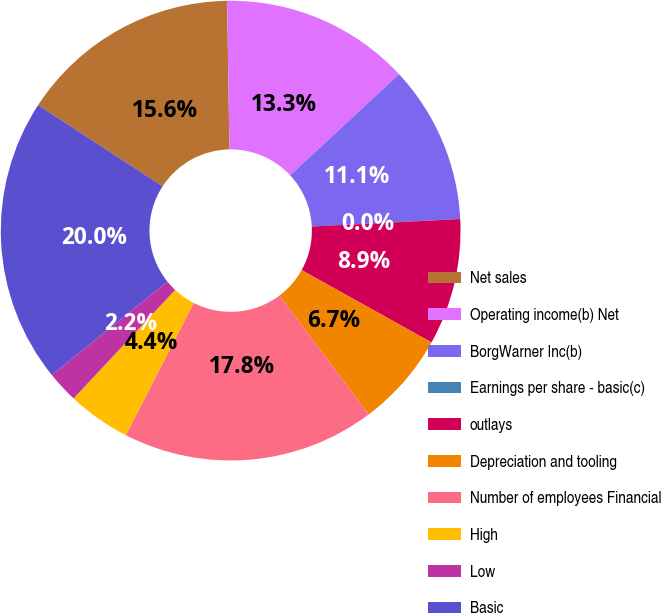<chart> <loc_0><loc_0><loc_500><loc_500><pie_chart><fcel>Net sales<fcel>Operating income(b) Net<fcel>BorgWarner Inc(b)<fcel>Earnings per share - basic(c)<fcel>outlays<fcel>Depreciation and tooling<fcel>Number of employees Financial<fcel>High<fcel>Low<fcel>Basic<nl><fcel>15.56%<fcel>13.33%<fcel>11.11%<fcel>0.0%<fcel>8.89%<fcel>6.67%<fcel>17.78%<fcel>4.44%<fcel>2.22%<fcel>20.0%<nl></chart> 